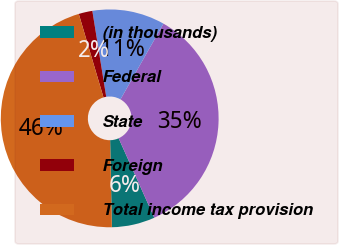Convert chart to OTSL. <chart><loc_0><loc_0><loc_500><loc_500><pie_chart><fcel>(in thousands)<fcel>Federal<fcel>State<fcel>Foreign<fcel>Total income tax provision<nl><fcel>6.4%<fcel>35.07%<fcel>10.77%<fcel>2.03%<fcel>45.74%<nl></chart> 